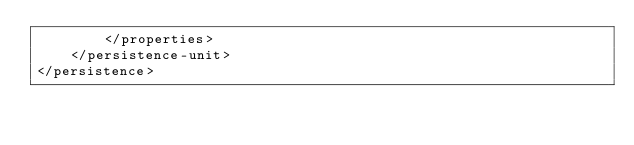<code> <loc_0><loc_0><loc_500><loc_500><_XML_>        </properties>
    </persistence-unit>
</persistence>
</code> 